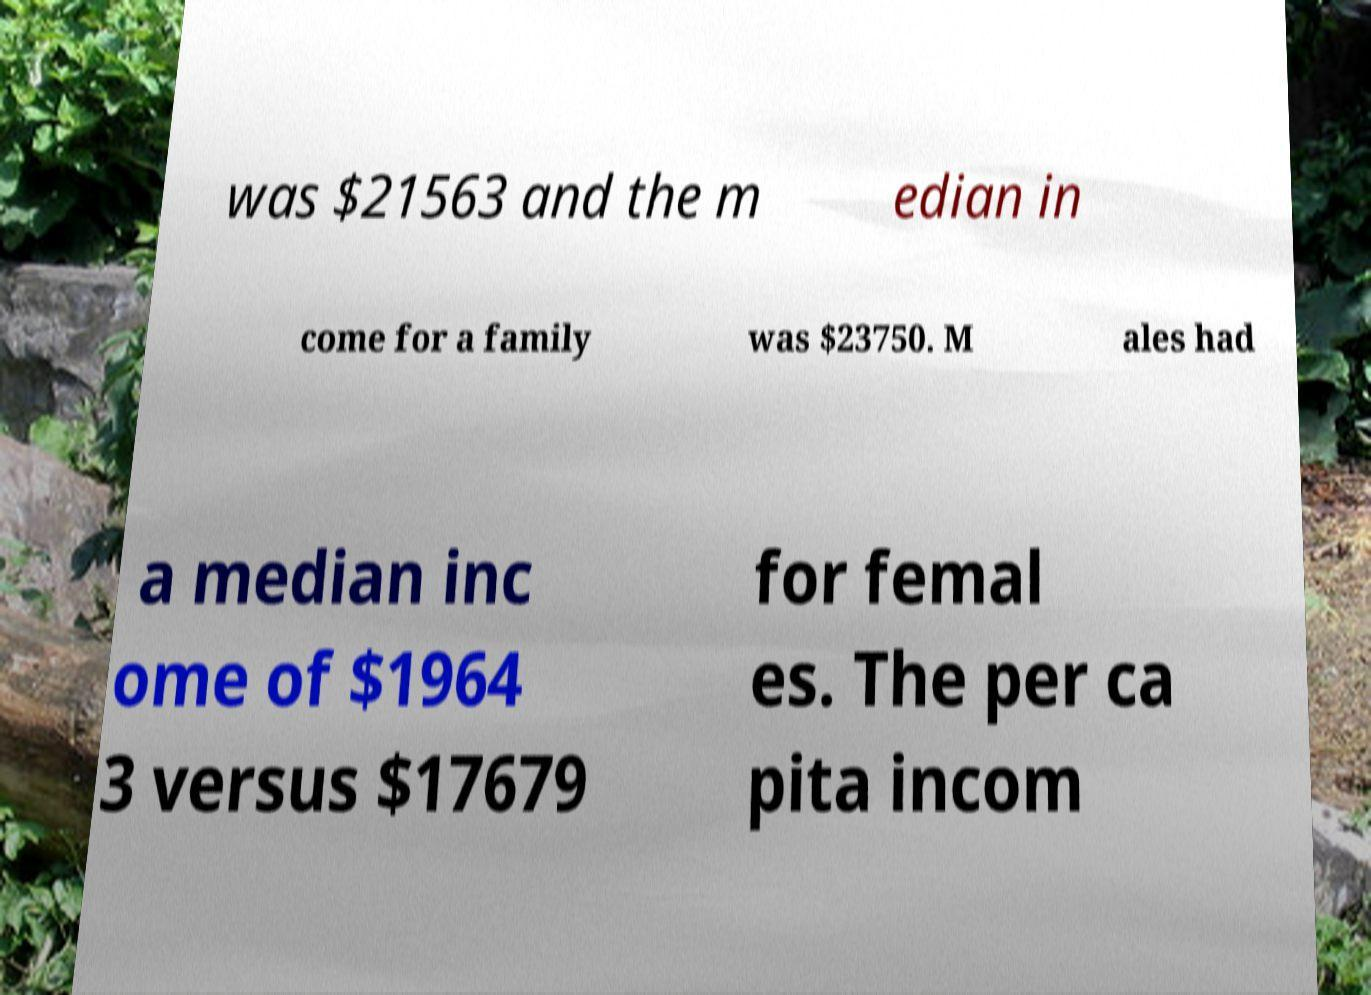There's text embedded in this image that I need extracted. Can you transcribe it verbatim? was $21563 and the m edian in come for a family was $23750. M ales had a median inc ome of $1964 3 versus $17679 for femal es. The per ca pita incom 